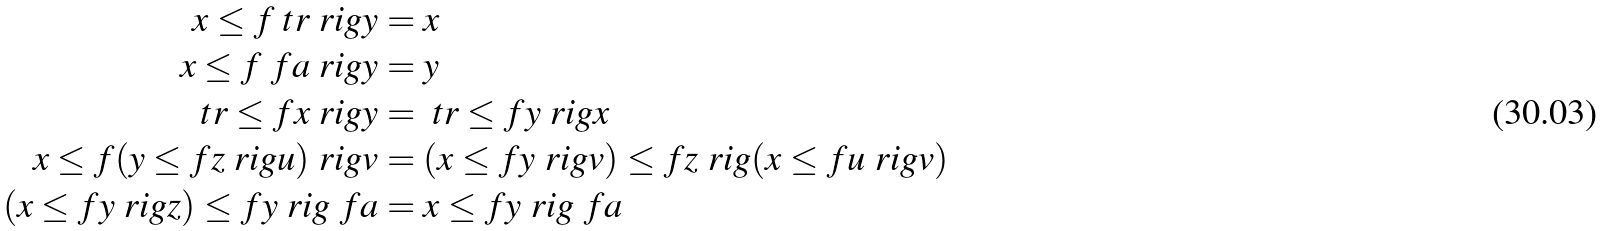<formula> <loc_0><loc_0><loc_500><loc_500>x \leq f \ t r \ r i g y & = x \\ x \leq f \ f a \ r i g y & = y \\ \ t r \leq f x \ r i g y & = \ t r \leq f y \ r i g x \\ x \leq f ( y \leq f z \ r i g u ) \ r i g v & = ( x \leq f y \ r i g v ) \leq f z \ r i g ( x \leq f u \ r i g v ) \\ \quad ( x \leq f y \ r i g z ) \leq f y \ r i g \ f a & = x \leq f y \ r i g \ f a</formula> 